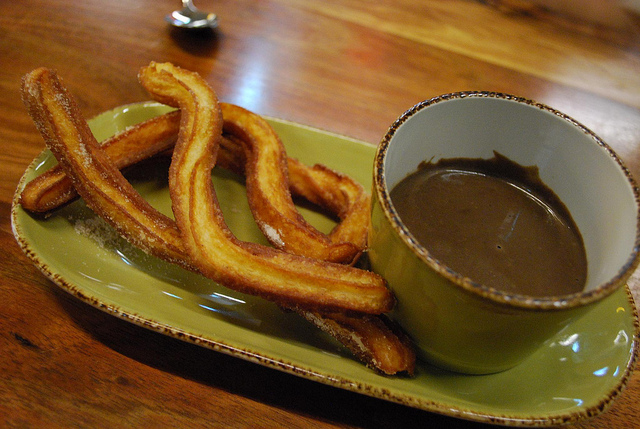Is this a well-balanced breakfast? No, this is not a well-balanced breakfast. It consists primarily of churros and chocolate, which are mainly sugary treats. 